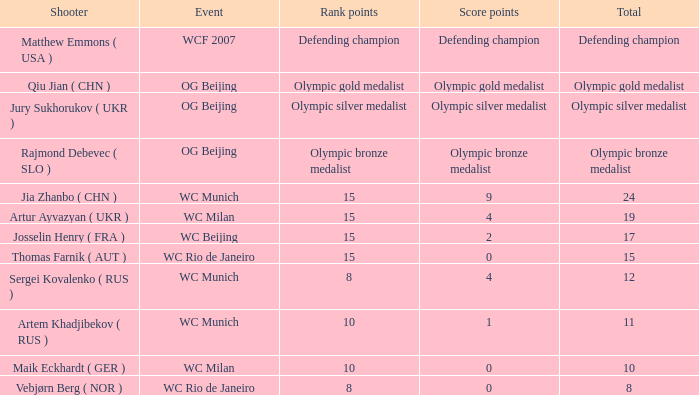Given a total of 11 and 10 rank points, how many score points are there? 1.0. Could you help me parse every detail presented in this table? {'header': ['Shooter', 'Event', 'Rank points', 'Score points', 'Total'], 'rows': [['Matthew Emmons ( USA )', 'WCF 2007', 'Defending champion', 'Defending champion', 'Defending champion'], ['Qiu Jian ( CHN )', 'OG Beijing', 'Olympic gold medalist', 'Olympic gold medalist', 'Olympic gold medalist'], ['Jury Sukhorukov ( UKR )', 'OG Beijing', 'Olympic silver medalist', 'Olympic silver medalist', 'Olympic silver medalist'], ['Rajmond Debevec ( SLO )', 'OG Beijing', 'Olympic bronze medalist', 'Olympic bronze medalist', 'Olympic bronze medalist'], ['Jia Zhanbo ( CHN )', 'WC Munich', '15', '9', '24'], ['Artur Ayvazyan ( UKR )', 'WC Milan', '15', '4', '19'], ['Josselin Henry ( FRA )', 'WC Beijing', '15', '2', '17'], ['Thomas Farnik ( AUT )', 'WC Rio de Janeiro', '15', '0', '15'], ['Sergei Kovalenko ( RUS )', 'WC Munich', '8', '4', '12'], ['Artem Khadjibekov ( RUS )', 'WC Munich', '10', '1', '11'], ['Maik Eckhardt ( GER )', 'WC Milan', '10', '0', '10'], ['Vebjørn Berg ( NOR )', 'WC Rio de Janeiro', '8', '0', '8']]} 